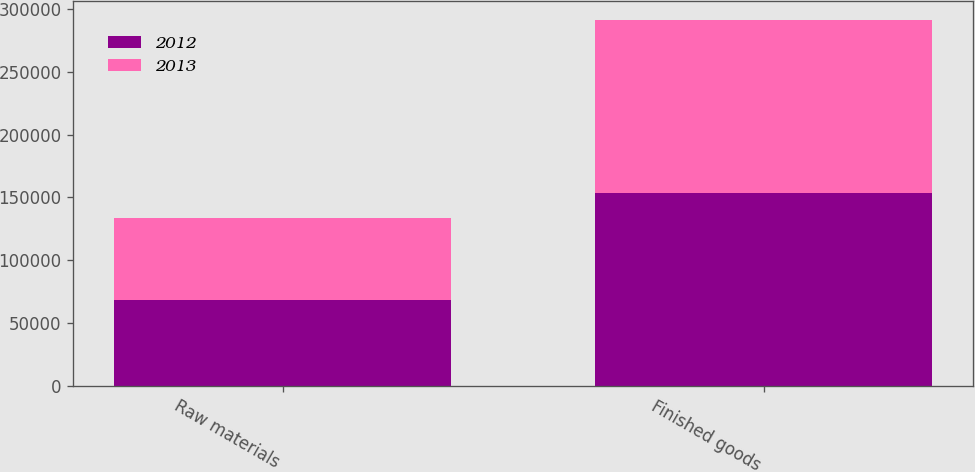Convert chart. <chart><loc_0><loc_0><loc_500><loc_500><stacked_bar_chart><ecel><fcel>Raw materials<fcel>Finished goods<nl><fcel>2012<fcel>68088<fcel>153361<nl><fcel>2013<fcel>65010<fcel>138096<nl></chart> 